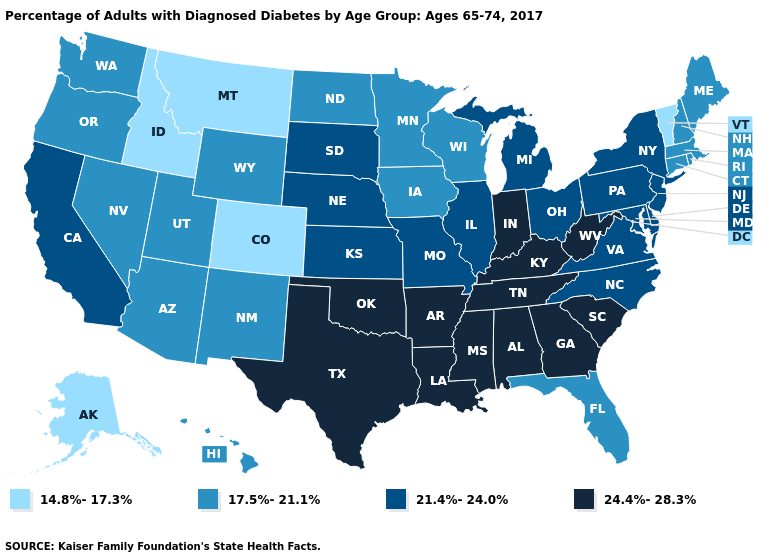What is the value of Idaho?
Quick response, please. 14.8%-17.3%. Name the states that have a value in the range 21.4%-24.0%?
Answer briefly. California, Delaware, Illinois, Kansas, Maryland, Michigan, Missouri, Nebraska, New Jersey, New York, North Carolina, Ohio, Pennsylvania, South Dakota, Virginia. Among the states that border Illinois , does Missouri have the lowest value?
Quick response, please. No. Does Oklahoma have the same value as Georgia?
Be succinct. Yes. What is the lowest value in the West?
Keep it brief. 14.8%-17.3%. Among the states that border Kansas , which have the highest value?
Give a very brief answer. Oklahoma. Name the states that have a value in the range 14.8%-17.3%?
Keep it brief. Alaska, Colorado, Idaho, Montana, Vermont. What is the lowest value in states that border Kentucky?
Keep it brief. 21.4%-24.0%. What is the value of Montana?
Give a very brief answer. 14.8%-17.3%. Does the map have missing data?
Write a very short answer. No. What is the highest value in the USA?
Write a very short answer. 24.4%-28.3%. Name the states that have a value in the range 14.8%-17.3%?
Be succinct. Alaska, Colorado, Idaho, Montana, Vermont. Does Alabama have the highest value in the USA?
Concise answer only. Yes. Does the map have missing data?
Keep it brief. No. Among the states that border Connecticut , which have the lowest value?
Concise answer only. Massachusetts, Rhode Island. 